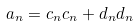<formula> <loc_0><loc_0><loc_500><loc_500>a _ { n } = c _ { n } c _ { n } + d _ { n } d _ { n }</formula> 